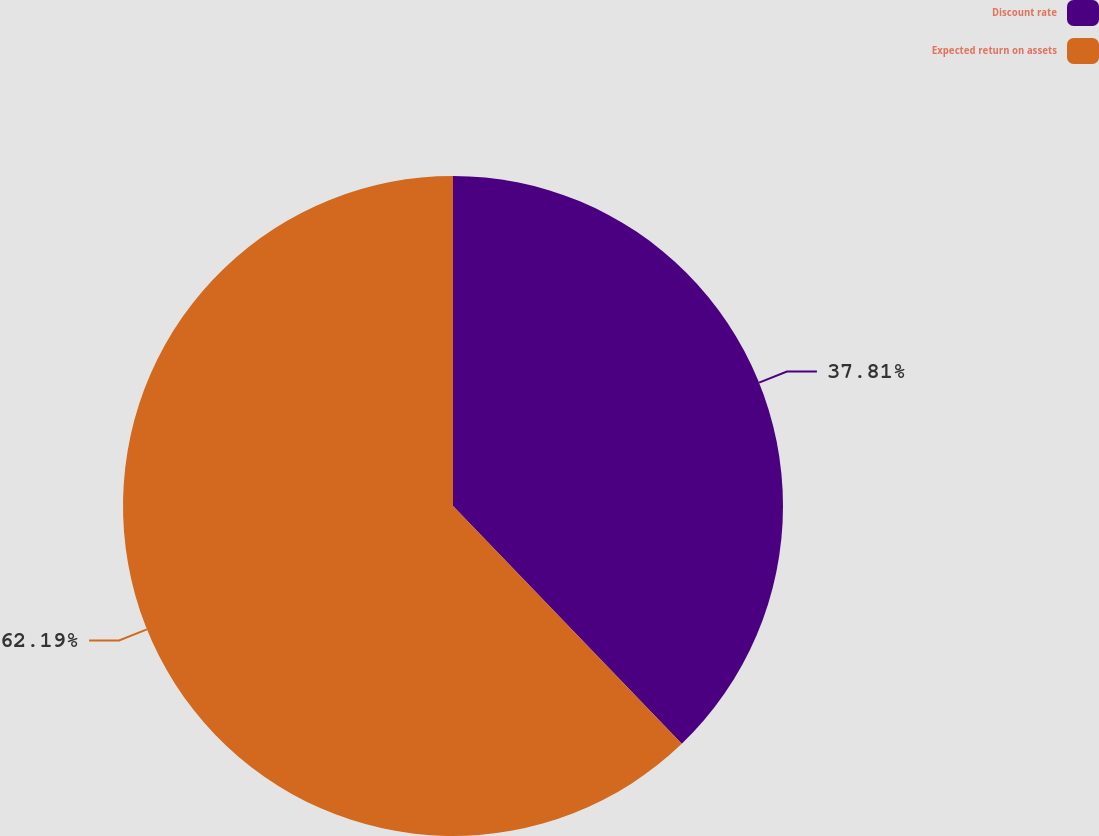Convert chart. <chart><loc_0><loc_0><loc_500><loc_500><pie_chart><fcel>Discount rate<fcel>Expected return on assets<nl><fcel>37.81%<fcel>62.19%<nl></chart> 